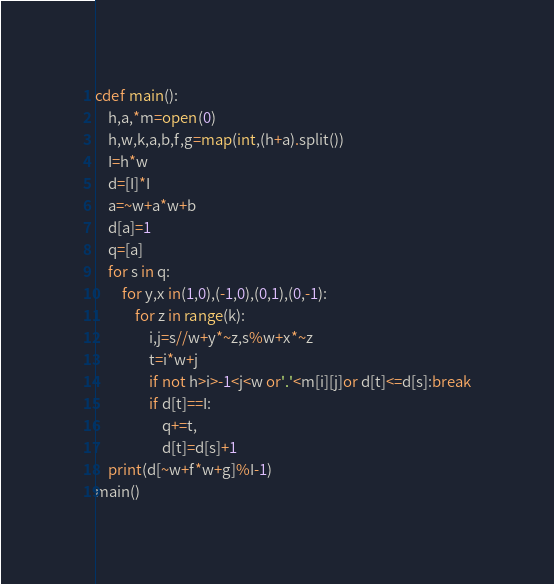Convert code to text. <code><loc_0><loc_0><loc_500><loc_500><_Cython_>cdef main():
    h,a,*m=open(0)
    h,w,k,a,b,f,g=map(int,(h+a).split())
    I=h*w
    d=[I]*I
    a=~w+a*w+b
    d[a]=1
    q=[a]
    for s in q:
        for y,x in(1,0),(-1,0),(0,1),(0,-1):
            for z in range(k):
                i,j=s//w+y*~z,s%w+x*~z
                t=i*w+j
                if not h>i>-1<j<w or'.'<m[i][j]or d[t]<=d[s]:break
                if d[t]==I:
                    q+=t,
                    d[t]=d[s]+1
    print(d[~w+f*w+g]%I-1)
main()</code> 